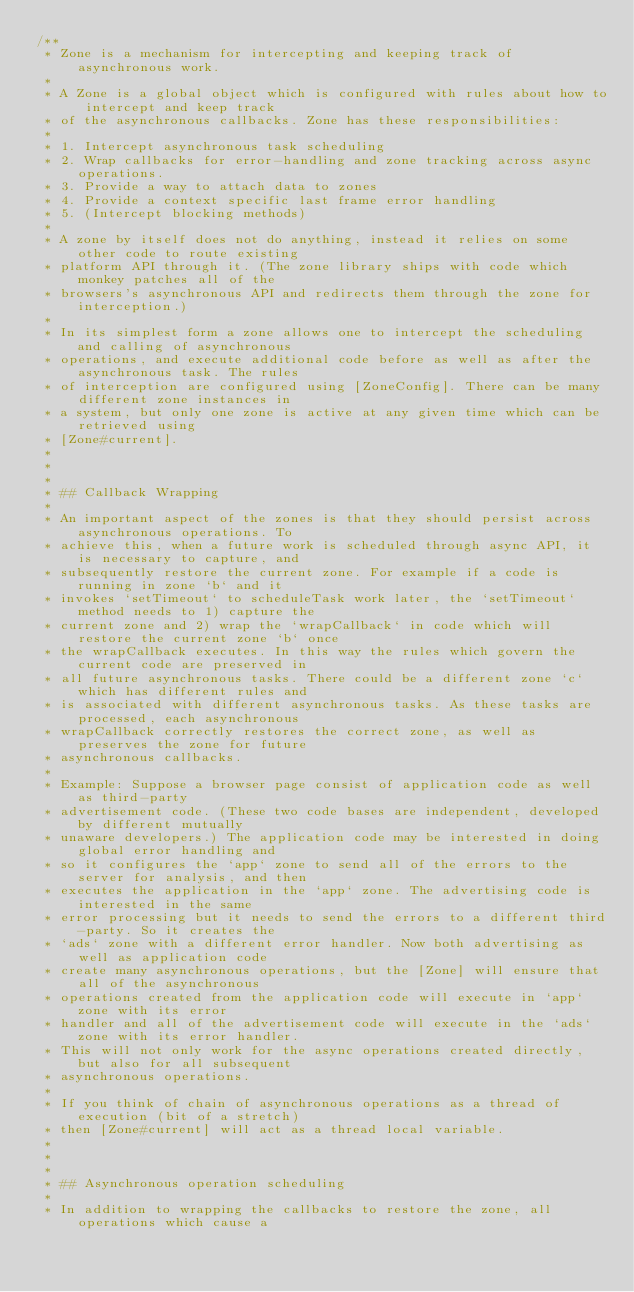Convert code to text. <code><loc_0><loc_0><loc_500><loc_500><_TypeScript_>/**
 * Zone is a mechanism for intercepting and keeping track of asynchronous work.
 *
 * A Zone is a global object which is configured with rules about how to intercept and keep track
 * of the asynchronous callbacks. Zone has these responsibilities:
 *
 * 1. Intercept asynchronous task scheduling
 * 2. Wrap callbacks for error-handling and zone tracking across async operations.
 * 3. Provide a way to attach data to zones
 * 4. Provide a context specific last frame error handling
 * 5. (Intercept blocking methods)
 *
 * A zone by itself does not do anything, instead it relies on some other code to route existing
 * platform API through it. (The zone library ships with code which monkey patches all of the
 * browsers's asynchronous API and redirects them through the zone for interception.)
 *
 * In its simplest form a zone allows one to intercept the scheduling and calling of asynchronous
 * operations, and execute additional code before as well as after the asynchronous task. The rules
 * of interception are configured using [ZoneConfig]. There can be many different zone instances in
 * a system, but only one zone is active at any given time which can be retrieved using
 * [Zone#current].
 *
 *
 *
 * ## Callback Wrapping
 *
 * An important aspect of the zones is that they should persist across asynchronous operations. To
 * achieve this, when a future work is scheduled through async API, it is necessary to capture, and
 * subsequently restore the current zone. For example if a code is running in zone `b` and it
 * invokes `setTimeout` to scheduleTask work later, the `setTimeout` method needs to 1) capture the
 * current zone and 2) wrap the `wrapCallback` in code which will restore the current zone `b` once
 * the wrapCallback executes. In this way the rules which govern the current code are preserved in
 * all future asynchronous tasks. There could be a different zone `c` which has different rules and
 * is associated with different asynchronous tasks. As these tasks are processed, each asynchronous
 * wrapCallback correctly restores the correct zone, as well as preserves the zone for future
 * asynchronous callbacks.
 *
 * Example: Suppose a browser page consist of application code as well as third-party
 * advertisement code. (These two code bases are independent, developed by different mutually
 * unaware developers.) The application code may be interested in doing global error handling and
 * so it configures the `app` zone to send all of the errors to the server for analysis, and then
 * executes the application in the `app` zone. The advertising code is interested in the same
 * error processing but it needs to send the errors to a different third-party. So it creates the
 * `ads` zone with a different error handler. Now both advertising as well as application code
 * create many asynchronous operations, but the [Zone] will ensure that all of the asynchronous
 * operations created from the application code will execute in `app` zone with its error
 * handler and all of the advertisement code will execute in the `ads` zone with its error handler.
 * This will not only work for the async operations created directly, but also for all subsequent
 * asynchronous operations.
 *
 * If you think of chain of asynchronous operations as a thread of execution (bit of a stretch)
 * then [Zone#current] will act as a thread local variable.
 *
 *
 *
 * ## Asynchronous operation scheduling
 *
 * In addition to wrapping the callbacks to restore the zone, all operations which cause a</code> 